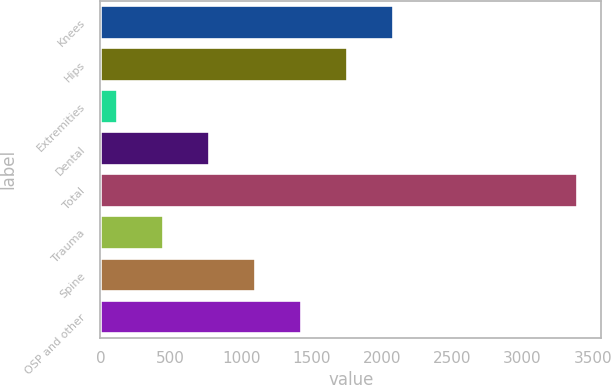<chart> <loc_0><loc_0><loc_500><loc_500><bar_chart><fcel>Knees<fcel>Hips<fcel>Extremities<fcel>Dental<fcel>Total<fcel>Trauma<fcel>Spine<fcel>OSP and other<nl><fcel>2083<fcel>1756<fcel>121<fcel>775<fcel>3391<fcel>448<fcel>1102<fcel>1429<nl></chart> 